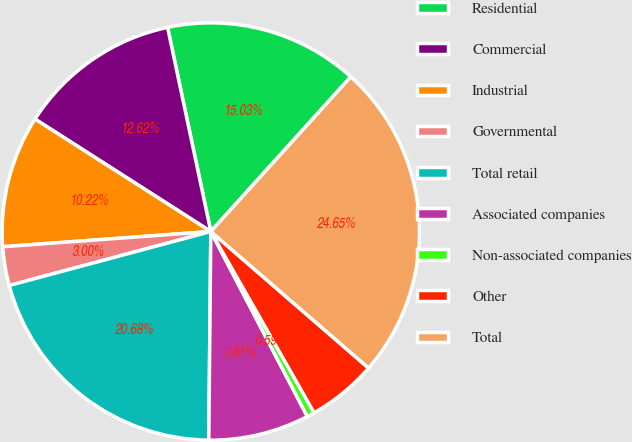Convert chart to OTSL. <chart><loc_0><loc_0><loc_500><loc_500><pie_chart><fcel>Residential<fcel>Commercial<fcel>Industrial<fcel>Governmental<fcel>Total retail<fcel>Associated companies<fcel>Non-associated companies<fcel>Other<fcel>Total<nl><fcel>15.03%<fcel>12.62%<fcel>10.22%<fcel>3.0%<fcel>20.68%<fcel>7.81%<fcel>0.59%<fcel>5.4%<fcel>24.65%<nl></chart> 